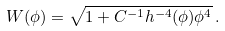<formula> <loc_0><loc_0><loc_500><loc_500>W ( \phi ) = \sqrt { 1 + C ^ { - 1 } h ^ { - 4 } ( \phi ) \phi ^ { 4 } } \, .</formula> 